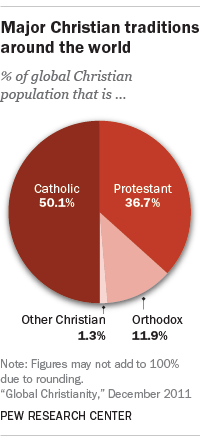Give some essential details in this illustration. What is the number of segments that have a value greater than 34%? Determine the result by taking the sum of the two largest segments, subtracting the smallest segment from the sum, and using the answer from the previous question. 